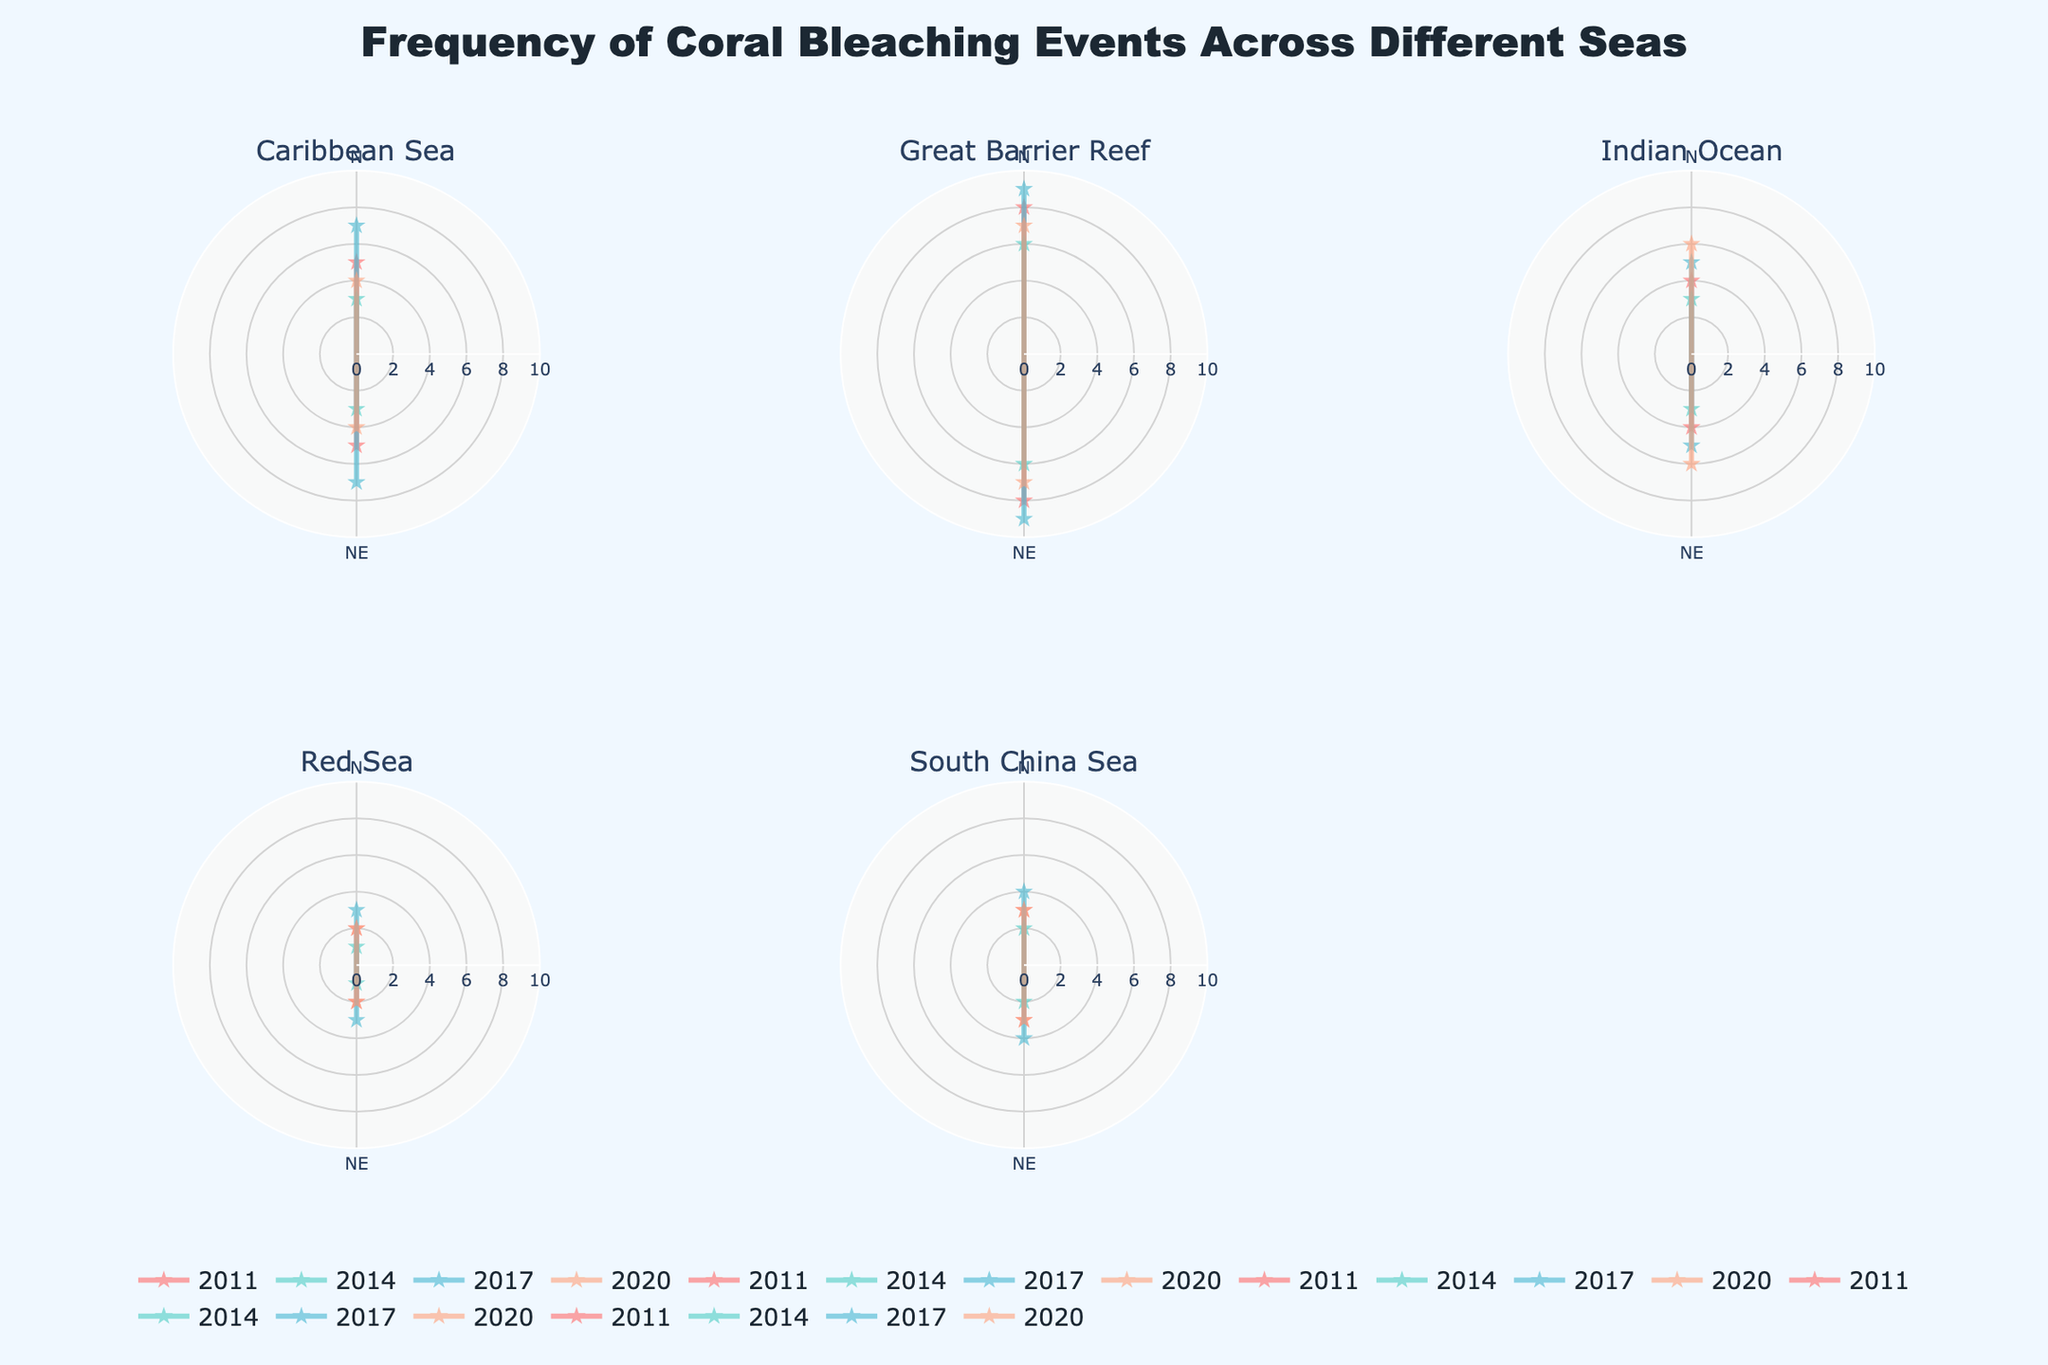What's the title of the figure? The title of the figure is located at the top center of the plot. From the provided layout, it states, "Frequency of Coral Bleaching Events Across Different Seas".
Answer: Frequency of Coral Bleaching Events Across Different Seas How many seas are represented in the figure? Each subplot in the figure represents a different sea. There are six subplots, each with a specific sea name as the subplot title.
Answer: Six In which sea and year was the highest frequency of coral bleaching events recorded? The subplot for the Great Barrier Reef shows the highest frequency in the year 2017 with a value of 9.
Answer: Great Barrier Reef, 2017 How does the frequency of coral bleaching events in the Red Sea in 2020 compare to 2011? Looking at the Red Sea's subplot, the frequency in 2020 is 2, which is the same as the frequency in 2011.
Answer: Equal Which year had the highest number of coral bleaching events in the Indian Ocean? By examining the Indian Ocean's subplot, 2020 shows the highest frequency with a value of 6.
Answer: 2020 Compare the trends of coral bleaching events in the Caribbean Sea and the South China Sea between 2011 and 2020. Both seas show an increase in the number of events from 2011 to 2017 and a slight decrease or stabilization in 2020. The Caribbean Sea shows fluctuations between years, while the South China Sea has more gradual changes.
Answer: Both show an increase followed by stabilization or slight decrease What is the average frequency of coral bleaching events in the Great Barrier Reef over the years shown? Summing the values from the Great Barrier Reef subplot (8 in 2011, 6 in 2014, 9 in 2017, 7 in 2020), the total is 30. Dividing by the number of years (4), the average frequency is 7.5.
Answer: 7.5 Which subplot shows the lowest frequency of coral bleaching events over all years? The Red Sea subplot shows the consistently lowest frequencies, with values mostly around 1 or 2.
Answer: Red Sea 